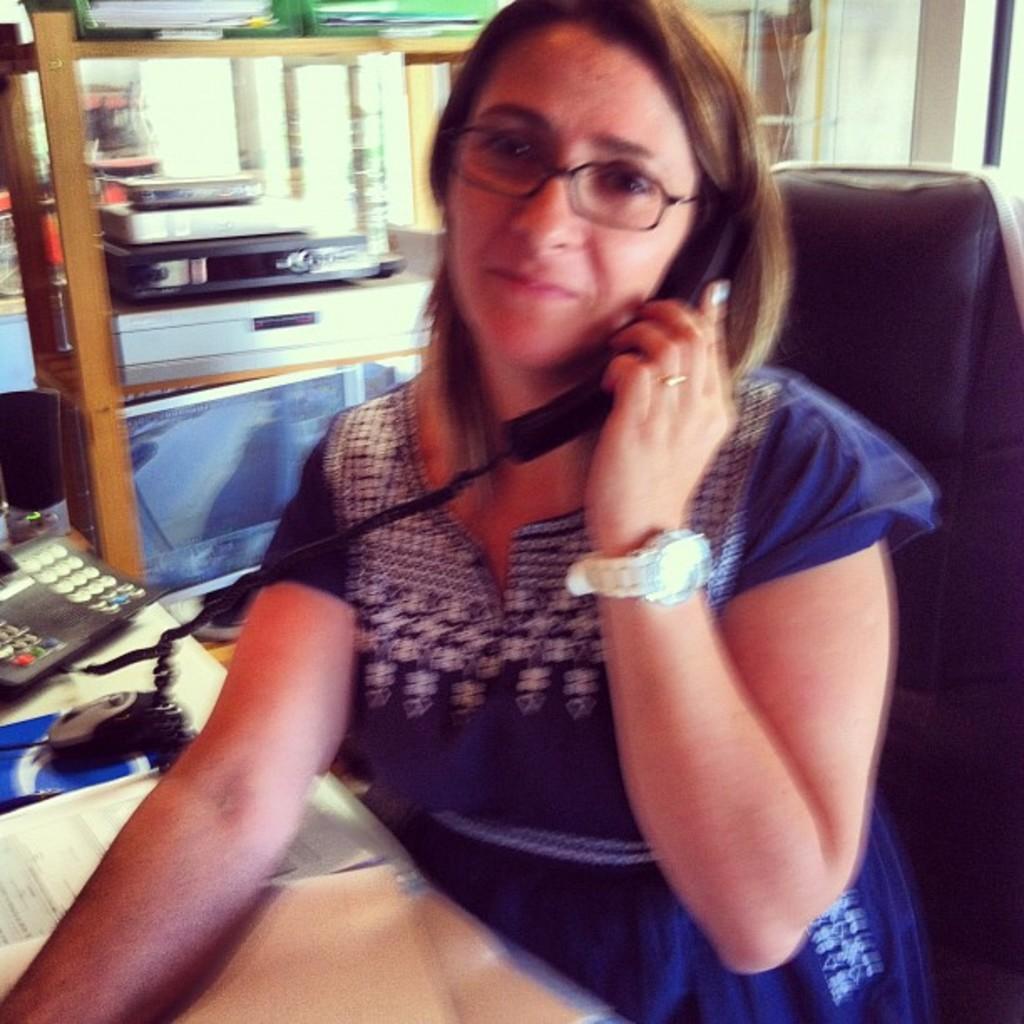In one or two sentences, can you explain what this image depicts? The woman in front of the picture is sitting on the chair. She is holding a phone in her hand. I think she is talking on the phone. She is wearing the spectacles. In front of her, we see a table on which landline phone, mouse, books and files are placed. Beside her, we see a table on which electronic goods are placed. In the background, we see a wall and the windows. 